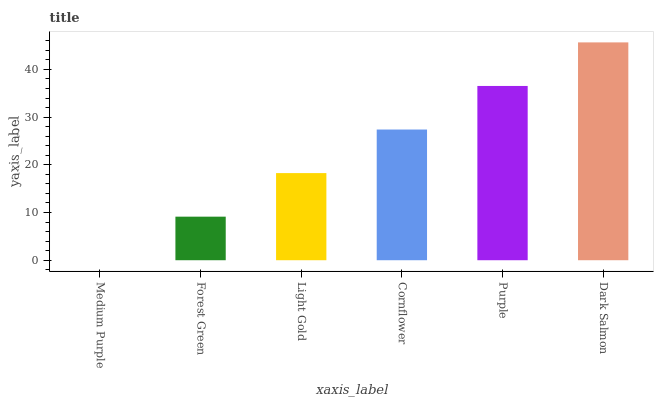Is Medium Purple the minimum?
Answer yes or no. Yes. Is Dark Salmon the maximum?
Answer yes or no. Yes. Is Forest Green the minimum?
Answer yes or no. No. Is Forest Green the maximum?
Answer yes or no. No. Is Forest Green greater than Medium Purple?
Answer yes or no. Yes. Is Medium Purple less than Forest Green?
Answer yes or no. Yes. Is Medium Purple greater than Forest Green?
Answer yes or no. No. Is Forest Green less than Medium Purple?
Answer yes or no. No. Is Cornflower the high median?
Answer yes or no. Yes. Is Light Gold the low median?
Answer yes or no. Yes. Is Light Gold the high median?
Answer yes or no. No. Is Purple the low median?
Answer yes or no. No. 